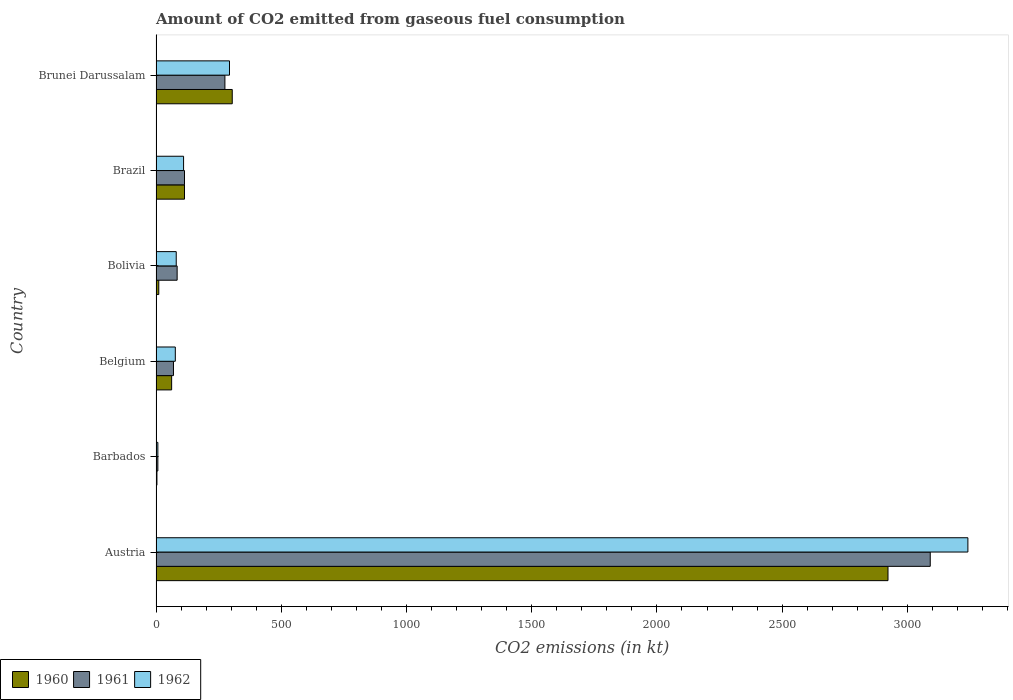How many different coloured bars are there?
Provide a short and direct response. 3. Are the number of bars on each tick of the Y-axis equal?
Make the answer very short. Yes. How many bars are there on the 3rd tick from the top?
Give a very brief answer. 3. How many bars are there on the 3rd tick from the bottom?
Your answer should be very brief. 3. What is the label of the 5th group of bars from the top?
Ensure brevity in your answer.  Barbados. What is the amount of CO2 emitted in 1962 in Barbados?
Offer a terse response. 7.33. Across all countries, what is the maximum amount of CO2 emitted in 1960?
Your response must be concise. 2922.6. Across all countries, what is the minimum amount of CO2 emitted in 1960?
Offer a terse response. 3.67. In which country was the amount of CO2 emitted in 1962 minimum?
Offer a terse response. Barbados. What is the total amount of CO2 emitted in 1961 in the graph?
Make the answer very short. 3641.33. What is the difference between the amount of CO2 emitted in 1960 in Barbados and that in Brunei Darussalam?
Your answer should be very brief. -300.69. What is the difference between the amount of CO2 emitted in 1960 in Brazil and the amount of CO2 emitted in 1962 in Austria?
Offer a very short reply. -3127.95. What is the average amount of CO2 emitted in 1961 per country?
Provide a succinct answer. 606.89. What is the difference between the amount of CO2 emitted in 1960 and amount of CO2 emitted in 1962 in Austria?
Offer a terse response. -319.03. In how many countries, is the amount of CO2 emitted in 1960 greater than 2900 kt?
Your response must be concise. 1. What is the ratio of the amount of CO2 emitted in 1962 in Barbados to that in Belgium?
Keep it short and to the point. 0.1. Is the amount of CO2 emitted in 1962 in Barbados less than that in Brazil?
Your answer should be very brief. Yes. Is the difference between the amount of CO2 emitted in 1960 in Barbados and Brazil greater than the difference between the amount of CO2 emitted in 1962 in Barbados and Brazil?
Your response must be concise. No. What is the difference between the highest and the second highest amount of CO2 emitted in 1960?
Your answer should be compact. 2618.24. What is the difference between the highest and the lowest amount of CO2 emitted in 1962?
Offer a terse response. 3234.29. What does the 3rd bar from the bottom in Brunei Darussalam represents?
Make the answer very short. 1962. How many bars are there?
Make the answer very short. 18. Are all the bars in the graph horizontal?
Ensure brevity in your answer.  Yes. What is the difference between two consecutive major ticks on the X-axis?
Offer a very short reply. 500. Does the graph contain grids?
Provide a succinct answer. No. How many legend labels are there?
Make the answer very short. 3. How are the legend labels stacked?
Your response must be concise. Horizontal. What is the title of the graph?
Offer a terse response. Amount of CO2 emitted from gaseous fuel consumption. What is the label or title of the X-axis?
Make the answer very short. CO2 emissions (in kt). What is the CO2 emissions (in kt) of 1960 in Austria?
Provide a short and direct response. 2922.6. What is the CO2 emissions (in kt) of 1961 in Austria?
Provide a succinct answer. 3091.28. What is the CO2 emissions (in kt) in 1962 in Austria?
Offer a terse response. 3241.63. What is the CO2 emissions (in kt) of 1960 in Barbados?
Provide a succinct answer. 3.67. What is the CO2 emissions (in kt) in 1961 in Barbados?
Ensure brevity in your answer.  7.33. What is the CO2 emissions (in kt) in 1962 in Barbados?
Offer a terse response. 7.33. What is the CO2 emissions (in kt) of 1960 in Belgium?
Your answer should be compact. 62.34. What is the CO2 emissions (in kt) of 1961 in Belgium?
Your response must be concise. 69.67. What is the CO2 emissions (in kt) in 1962 in Belgium?
Give a very brief answer. 77.01. What is the CO2 emissions (in kt) in 1960 in Bolivia?
Your answer should be very brief. 11. What is the CO2 emissions (in kt) of 1961 in Bolivia?
Offer a very short reply. 84.34. What is the CO2 emissions (in kt) in 1962 in Bolivia?
Offer a very short reply. 80.67. What is the CO2 emissions (in kt) of 1960 in Brazil?
Offer a very short reply. 113.68. What is the CO2 emissions (in kt) of 1961 in Brazil?
Give a very brief answer. 113.68. What is the CO2 emissions (in kt) in 1962 in Brazil?
Provide a succinct answer. 110.01. What is the CO2 emissions (in kt) of 1960 in Brunei Darussalam?
Give a very brief answer. 304.36. What is the CO2 emissions (in kt) in 1961 in Brunei Darussalam?
Give a very brief answer. 275.02. What is the CO2 emissions (in kt) in 1962 in Brunei Darussalam?
Provide a short and direct response. 293.36. Across all countries, what is the maximum CO2 emissions (in kt) in 1960?
Ensure brevity in your answer.  2922.6. Across all countries, what is the maximum CO2 emissions (in kt) in 1961?
Your answer should be compact. 3091.28. Across all countries, what is the maximum CO2 emissions (in kt) of 1962?
Keep it short and to the point. 3241.63. Across all countries, what is the minimum CO2 emissions (in kt) in 1960?
Your response must be concise. 3.67. Across all countries, what is the minimum CO2 emissions (in kt) in 1961?
Your answer should be compact. 7.33. Across all countries, what is the minimum CO2 emissions (in kt) of 1962?
Ensure brevity in your answer.  7.33. What is the total CO2 emissions (in kt) in 1960 in the graph?
Provide a short and direct response. 3417.64. What is the total CO2 emissions (in kt) of 1961 in the graph?
Offer a very short reply. 3641.33. What is the total CO2 emissions (in kt) in 1962 in the graph?
Offer a very short reply. 3810.01. What is the difference between the CO2 emissions (in kt) of 1960 in Austria and that in Barbados?
Your answer should be very brief. 2918.93. What is the difference between the CO2 emissions (in kt) in 1961 in Austria and that in Barbados?
Give a very brief answer. 3083.95. What is the difference between the CO2 emissions (in kt) in 1962 in Austria and that in Barbados?
Keep it short and to the point. 3234.29. What is the difference between the CO2 emissions (in kt) in 1960 in Austria and that in Belgium?
Offer a very short reply. 2860.26. What is the difference between the CO2 emissions (in kt) in 1961 in Austria and that in Belgium?
Make the answer very short. 3021.61. What is the difference between the CO2 emissions (in kt) of 1962 in Austria and that in Belgium?
Make the answer very short. 3164.62. What is the difference between the CO2 emissions (in kt) of 1960 in Austria and that in Bolivia?
Provide a short and direct response. 2911.6. What is the difference between the CO2 emissions (in kt) of 1961 in Austria and that in Bolivia?
Your answer should be very brief. 3006.94. What is the difference between the CO2 emissions (in kt) of 1962 in Austria and that in Bolivia?
Your response must be concise. 3160.95. What is the difference between the CO2 emissions (in kt) in 1960 in Austria and that in Brazil?
Ensure brevity in your answer.  2808.92. What is the difference between the CO2 emissions (in kt) of 1961 in Austria and that in Brazil?
Your response must be concise. 2977.6. What is the difference between the CO2 emissions (in kt) in 1962 in Austria and that in Brazil?
Keep it short and to the point. 3131.62. What is the difference between the CO2 emissions (in kt) in 1960 in Austria and that in Brunei Darussalam?
Offer a terse response. 2618.24. What is the difference between the CO2 emissions (in kt) of 1961 in Austria and that in Brunei Darussalam?
Offer a very short reply. 2816.26. What is the difference between the CO2 emissions (in kt) in 1962 in Austria and that in Brunei Darussalam?
Make the answer very short. 2948.27. What is the difference between the CO2 emissions (in kt) in 1960 in Barbados and that in Belgium?
Ensure brevity in your answer.  -58.67. What is the difference between the CO2 emissions (in kt) of 1961 in Barbados and that in Belgium?
Provide a succinct answer. -62.34. What is the difference between the CO2 emissions (in kt) of 1962 in Barbados and that in Belgium?
Provide a succinct answer. -69.67. What is the difference between the CO2 emissions (in kt) in 1960 in Barbados and that in Bolivia?
Provide a succinct answer. -7.33. What is the difference between the CO2 emissions (in kt) in 1961 in Barbados and that in Bolivia?
Offer a terse response. -77.01. What is the difference between the CO2 emissions (in kt) of 1962 in Barbados and that in Bolivia?
Ensure brevity in your answer.  -73.34. What is the difference between the CO2 emissions (in kt) in 1960 in Barbados and that in Brazil?
Offer a very short reply. -110.01. What is the difference between the CO2 emissions (in kt) of 1961 in Barbados and that in Brazil?
Give a very brief answer. -106.34. What is the difference between the CO2 emissions (in kt) of 1962 in Barbados and that in Brazil?
Your answer should be compact. -102.68. What is the difference between the CO2 emissions (in kt) of 1960 in Barbados and that in Brunei Darussalam?
Your answer should be compact. -300.69. What is the difference between the CO2 emissions (in kt) of 1961 in Barbados and that in Brunei Darussalam?
Give a very brief answer. -267.69. What is the difference between the CO2 emissions (in kt) in 1962 in Barbados and that in Brunei Darussalam?
Keep it short and to the point. -286.03. What is the difference between the CO2 emissions (in kt) in 1960 in Belgium and that in Bolivia?
Your answer should be very brief. 51.34. What is the difference between the CO2 emissions (in kt) of 1961 in Belgium and that in Bolivia?
Give a very brief answer. -14.67. What is the difference between the CO2 emissions (in kt) in 1962 in Belgium and that in Bolivia?
Give a very brief answer. -3.67. What is the difference between the CO2 emissions (in kt) in 1960 in Belgium and that in Brazil?
Keep it short and to the point. -51.34. What is the difference between the CO2 emissions (in kt) in 1961 in Belgium and that in Brazil?
Provide a succinct answer. -44. What is the difference between the CO2 emissions (in kt) in 1962 in Belgium and that in Brazil?
Provide a succinct answer. -33. What is the difference between the CO2 emissions (in kt) of 1960 in Belgium and that in Brunei Darussalam?
Your answer should be very brief. -242.02. What is the difference between the CO2 emissions (in kt) of 1961 in Belgium and that in Brunei Darussalam?
Provide a short and direct response. -205.35. What is the difference between the CO2 emissions (in kt) of 1962 in Belgium and that in Brunei Darussalam?
Offer a terse response. -216.35. What is the difference between the CO2 emissions (in kt) in 1960 in Bolivia and that in Brazil?
Your answer should be very brief. -102.68. What is the difference between the CO2 emissions (in kt) in 1961 in Bolivia and that in Brazil?
Your answer should be very brief. -29.34. What is the difference between the CO2 emissions (in kt) in 1962 in Bolivia and that in Brazil?
Provide a succinct answer. -29.34. What is the difference between the CO2 emissions (in kt) of 1960 in Bolivia and that in Brunei Darussalam?
Offer a terse response. -293.36. What is the difference between the CO2 emissions (in kt) in 1961 in Bolivia and that in Brunei Darussalam?
Your answer should be very brief. -190.68. What is the difference between the CO2 emissions (in kt) in 1962 in Bolivia and that in Brunei Darussalam?
Your response must be concise. -212.69. What is the difference between the CO2 emissions (in kt) in 1960 in Brazil and that in Brunei Darussalam?
Give a very brief answer. -190.68. What is the difference between the CO2 emissions (in kt) of 1961 in Brazil and that in Brunei Darussalam?
Offer a very short reply. -161.35. What is the difference between the CO2 emissions (in kt) in 1962 in Brazil and that in Brunei Darussalam?
Give a very brief answer. -183.35. What is the difference between the CO2 emissions (in kt) of 1960 in Austria and the CO2 emissions (in kt) of 1961 in Barbados?
Ensure brevity in your answer.  2915.26. What is the difference between the CO2 emissions (in kt) in 1960 in Austria and the CO2 emissions (in kt) in 1962 in Barbados?
Your answer should be very brief. 2915.26. What is the difference between the CO2 emissions (in kt) of 1961 in Austria and the CO2 emissions (in kt) of 1962 in Barbados?
Give a very brief answer. 3083.95. What is the difference between the CO2 emissions (in kt) in 1960 in Austria and the CO2 emissions (in kt) in 1961 in Belgium?
Offer a terse response. 2852.93. What is the difference between the CO2 emissions (in kt) of 1960 in Austria and the CO2 emissions (in kt) of 1962 in Belgium?
Keep it short and to the point. 2845.59. What is the difference between the CO2 emissions (in kt) of 1961 in Austria and the CO2 emissions (in kt) of 1962 in Belgium?
Make the answer very short. 3014.27. What is the difference between the CO2 emissions (in kt) in 1960 in Austria and the CO2 emissions (in kt) in 1961 in Bolivia?
Give a very brief answer. 2838.26. What is the difference between the CO2 emissions (in kt) in 1960 in Austria and the CO2 emissions (in kt) in 1962 in Bolivia?
Provide a succinct answer. 2841.93. What is the difference between the CO2 emissions (in kt) in 1961 in Austria and the CO2 emissions (in kt) in 1962 in Bolivia?
Provide a succinct answer. 3010.61. What is the difference between the CO2 emissions (in kt) in 1960 in Austria and the CO2 emissions (in kt) in 1961 in Brazil?
Your response must be concise. 2808.92. What is the difference between the CO2 emissions (in kt) in 1960 in Austria and the CO2 emissions (in kt) in 1962 in Brazil?
Your answer should be very brief. 2812.59. What is the difference between the CO2 emissions (in kt) of 1961 in Austria and the CO2 emissions (in kt) of 1962 in Brazil?
Your response must be concise. 2981.27. What is the difference between the CO2 emissions (in kt) in 1960 in Austria and the CO2 emissions (in kt) in 1961 in Brunei Darussalam?
Your answer should be compact. 2647.57. What is the difference between the CO2 emissions (in kt) in 1960 in Austria and the CO2 emissions (in kt) in 1962 in Brunei Darussalam?
Provide a succinct answer. 2629.24. What is the difference between the CO2 emissions (in kt) in 1961 in Austria and the CO2 emissions (in kt) in 1962 in Brunei Darussalam?
Your answer should be compact. 2797.92. What is the difference between the CO2 emissions (in kt) in 1960 in Barbados and the CO2 emissions (in kt) in 1961 in Belgium?
Your answer should be compact. -66.01. What is the difference between the CO2 emissions (in kt) of 1960 in Barbados and the CO2 emissions (in kt) of 1962 in Belgium?
Give a very brief answer. -73.34. What is the difference between the CO2 emissions (in kt) of 1961 in Barbados and the CO2 emissions (in kt) of 1962 in Belgium?
Offer a very short reply. -69.67. What is the difference between the CO2 emissions (in kt) of 1960 in Barbados and the CO2 emissions (in kt) of 1961 in Bolivia?
Ensure brevity in your answer.  -80.67. What is the difference between the CO2 emissions (in kt) of 1960 in Barbados and the CO2 emissions (in kt) of 1962 in Bolivia?
Provide a succinct answer. -77.01. What is the difference between the CO2 emissions (in kt) in 1961 in Barbados and the CO2 emissions (in kt) in 1962 in Bolivia?
Offer a terse response. -73.34. What is the difference between the CO2 emissions (in kt) in 1960 in Barbados and the CO2 emissions (in kt) in 1961 in Brazil?
Provide a succinct answer. -110.01. What is the difference between the CO2 emissions (in kt) in 1960 in Barbados and the CO2 emissions (in kt) in 1962 in Brazil?
Provide a short and direct response. -106.34. What is the difference between the CO2 emissions (in kt) in 1961 in Barbados and the CO2 emissions (in kt) in 1962 in Brazil?
Offer a very short reply. -102.68. What is the difference between the CO2 emissions (in kt) in 1960 in Barbados and the CO2 emissions (in kt) in 1961 in Brunei Darussalam?
Give a very brief answer. -271.36. What is the difference between the CO2 emissions (in kt) in 1960 in Barbados and the CO2 emissions (in kt) in 1962 in Brunei Darussalam?
Your answer should be very brief. -289.69. What is the difference between the CO2 emissions (in kt) in 1961 in Barbados and the CO2 emissions (in kt) in 1962 in Brunei Darussalam?
Your response must be concise. -286.03. What is the difference between the CO2 emissions (in kt) in 1960 in Belgium and the CO2 emissions (in kt) in 1961 in Bolivia?
Keep it short and to the point. -22. What is the difference between the CO2 emissions (in kt) of 1960 in Belgium and the CO2 emissions (in kt) of 1962 in Bolivia?
Provide a short and direct response. -18.34. What is the difference between the CO2 emissions (in kt) of 1961 in Belgium and the CO2 emissions (in kt) of 1962 in Bolivia?
Make the answer very short. -11. What is the difference between the CO2 emissions (in kt) in 1960 in Belgium and the CO2 emissions (in kt) in 1961 in Brazil?
Keep it short and to the point. -51.34. What is the difference between the CO2 emissions (in kt) of 1960 in Belgium and the CO2 emissions (in kt) of 1962 in Brazil?
Make the answer very short. -47.67. What is the difference between the CO2 emissions (in kt) in 1961 in Belgium and the CO2 emissions (in kt) in 1962 in Brazil?
Your answer should be very brief. -40.34. What is the difference between the CO2 emissions (in kt) of 1960 in Belgium and the CO2 emissions (in kt) of 1961 in Brunei Darussalam?
Ensure brevity in your answer.  -212.69. What is the difference between the CO2 emissions (in kt) in 1960 in Belgium and the CO2 emissions (in kt) in 1962 in Brunei Darussalam?
Provide a succinct answer. -231.02. What is the difference between the CO2 emissions (in kt) of 1961 in Belgium and the CO2 emissions (in kt) of 1962 in Brunei Darussalam?
Your answer should be compact. -223.69. What is the difference between the CO2 emissions (in kt) in 1960 in Bolivia and the CO2 emissions (in kt) in 1961 in Brazil?
Provide a short and direct response. -102.68. What is the difference between the CO2 emissions (in kt) of 1960 in Bolivia and the CO2 emissions (in kt) of 1962 in Brazil?
Keep it short and to the point. -99.01. What is the difference between the CO2 emissions (in kt) in 1961 in Bolivia and the CO2 emissions (in kt) in 1962 in Brazil?
Offer a very short reply. -25.67. What is the difference between the CO2 emissions (in kt) in 1960 in Bolivia and the CO2 emissions (in kt) in 1961 in Brunei Darussalam?
Provide a succinct answer. -264.02. What is the difference between the CO2 emissions (in kt) of 1960 in Bolivia and the CO2 emissions (in kt) of 1962 in Brunei Darussalam?
Your answer should be very brief. -282.36. What is the difference between the CO2 emissions (in kt) of 1961 in Bolivia and the CO2 emissions (in kt) of 1962 in Brunei Darussalam?
Offer a very short reply. -209.02. What is the difference between the CO2 emissions (in kt) in 1960 in Brazil and the CO2 emissions (in kt) in 1961 in Brunei Darussalam?
Provide a short and direct response. -161.35. What is the difference between the CO2 emissions (in kt) in 1960 in Brazil and the CO2 emissions (in kt) in 1962 in Brunei Darussalam?
Keep it short and to the point. -179.68. What is the difference between the CO2 emissions (in kt) of 1961 in Brazil and the CO2 emissions (in kt) of 1962 in Brunei Darussalam?
Your answer should be very brief. -179.68. What is the average CO2 emissions (in kt) of 1960 per country?
Make the answer very short. 569.61. What is the average CO2 emissions (in kt) in 1961 per country?
Offer a terse response. 606.89. What is the average CO2 emissions (in kt) of 1962 per country?
Provide a short and direct response. 635. What is the difference between the CO2 emissions (in kt) in 1960 and CO2 emissions (in kt) in 1961 in Austria?
Ensure brevity in your answer.  -168.68. What is the difference between the CO2 emissions (in kt) of 1960 and CO2 emissions (in kt) of 1962 in Austria?
Your answer should be compact. -319.03. What is the difference between the CO2 emissions (in kt) of 1961 and CO2 emissions (in kt) of 1962 in Austria?
Give a very brief answer. -150.35. What is the difference between the CO2 emissions (in kt) in 1960 and CO2 emissions (in kt) in 1961 in Barbados?
Make the answer very short. -3.67. What is the difference between the CO2 emissions (in kt) of 1960 and CO2 emissions (in kt) of 1962 in Barbados?
Your answer should be compact. -3.67. What is the difference between the CO2 emissions (in kt) of 1961 and CO2 emissions (in kt) of 1962 in Barbados?
Ensure brevity in your answer.  0. What is the difference between the CO2 emissions (in kt) in 1960 and CO2 emissions (in kt) in 1961 in Belgium?
Keep it short and to the point. -7.33. What is the difference between the CO2 emissions (in kt) of 1960 and CO2 emissions (in kt) of 1962 in Belgium?
Your response must be concise. -14.67. What is the difference between the CO2 emissions (in kt) in 1961 and CO2 emissions (in kt) in 1962 in Belgium?
Provide a short and direct response. -7.33. What is the difference between the CO2 emissions (in kt) of 1960 and CO2 emissions (in kt) of 1961 in Bolivia?
Give a very brief answer. -73.34. What is the difference between the CO2 emissions (in kt) in 1960 and CO2 emissions (in kt) in 1962 in Bolivia?
Provide a short and direct response. -69.67. What is the difference between the CO2 emissions (in kt) of 1961 and CO2 emissions (in kt) of 1962 in Bolivia?
Offer a terse response. 3.67. What is the difference between the CO2 emissions (in kt) of 1960 and CO2 emissions (in kt) of 1962 in Brazil?
Keep it short and to the point. 3.67. What is the difference between the CO2 emissions (in kt) of 1961 and CO2 emissions (in kt) of 1962 in Brazil?
Your answer should be compact. 3.67. What is the difference between the CO2 emissions (in kt) in 1960 and CO2 emissions (in kt) in 1961 in Brunei Darussalam?
Make the answer very short. 29.34. What is the difference between the CO2 emissions (in kt) in 1960 and CO2 emissions (in kt) in 1962 in Brunei Darussalam?
Provide a succinct answer. 11. What is the difference between the CO2 emissions (in kt) of 1961 and CO2 emissions (in kt) of 1962 in Brunei Darussalam?
Your response must be concise. -18.34. What is the ratio of the CO2 emissions (in kt) in 1960 in Austria to that in Barbados?
Provide a succinct answer. 797. What is the ratio of the CO2 emissions (in kt) of 1961 in Austria to that in Barbados?
Provide a succinct answer. 421.5. What is the ratio of the CO2 emissions (in kt) in 1962 in Austria to that in Barbados?
Make the answer very short. 442. What is the ratio of the CO2 emissions (in kt) of 1960 in Austria to that in Belgium?
Keep it short and to the point. 46.88. What is the ratio of the CO2 emissions (in kt) of 1961 in Austria to that in Belgium?
Your answer should be compact. 44.37. What is the ratio of the CO2 emissions (in kt) in 1962 in Austria to that in Belgium?
Your answer should be very brief. 42.1. What is the ratio of the CO2 emissions (in kt) in 1960 in Austria to that in Bolivia?
Your response must be concise. 265.67. What is the ratio of the CO2 emissions (in kt) of 1961 in Austria to that in Bolivia?
Your answer should be very brief. 36.65. What is the ratio of the CO2 emissions (in kt) in 1962 in Austria to that in Bolivia?
Your answer should be very brief. 40.18. What is the ratio of the CO2 emissions (in kt) in 1960 in Austria to that in Brazil?
Give a very brief answer. 25.71. What is the ratio of the CO2 emissions (in kt) of 1961 in Austria to that in Brazil?
Your answer should be compact. 27.19. What is the ratio of the CO2 emissions (in kt) in 1962 in Austria to that in Brazil?
Make the answer very short. 29.47. What is the ratio of the CO2 emissions (in kt) of 1960 in Austria to that in Brunei Darussalam?
Offer a terse response. 9.6. What is the ratio of the CO2 emissions (in kt) in 1961 in Austria to that in Brunei Darussalam?
Your response must be concise. 11.24. What is the ratio of the CO2 emissions (in kt) of 1962 in Austria to that in Brunei Darussalam?
Offer a terse response. 11.05. What is the ratio of the CO2 emissions (in kt) in 1960 in Barbados to that in Belgium?
Your response must be concise. 0.06. What is the ratio of the CO2 emissions (in kt) of 1961 in Barbados to that in Belgium?
Your answer should be compact. 0.11. What is the ratio of the CO2 emissions (in kt) of 1962 in Barbados to that in Belgium?
Ensure brevity in your answer.  0.1. What is the ratio of the CO2 emissions (in kt) in 1961 in Barbados to that in Bolivia?
Keep it short and to the point. 0.09. What is the ratio of the CO2 emissions (in kt) of 1962 in Barbados to that in Bolivia?
Provide a succinct answer. 0.09. What is the ratio of the CO2 emissions (in kt) in 1960 in Barbados to that in Brazil?
Make the answer very short. 0.03. What is the ratio of the CO2 emissions (in kt) of 1961 in Barbados to that in Brazil?
Give a very brief answer. 0.06. What is the ratio of the CO2 emissions (in kt) in 1962 in Barbados to that in Brazil?
Your response must be concise. 0.07. What is the ratio of the CO2 emissions (in kt) of 1960 in Barbados to that in Brunei Darussalam?
Your answer should be very brief. 0.01. What is the ratio of the CO2 emissions (in kt) in 1961 in Barbados to that in Brunei Darussalam?
Ensure brevity in your answer.  0.03. What is the ratio of the CO2 emissions (in kt) of 1962 in Barbados to that in Brunei Darussalam?
Offer a very short reply. 0.03. What is the ratio of the CO2 emissions (in kt) of 1960 in Belgium to that in Bolivia?
Your response must be concise. 5.67. What is the ratio of the CO2 emissions (in kt) of 1961 in Belgium to that in Bolivia?
Your response must be concise. 0.83. What is the ratio of the CO2 emissions (in kt) of 1962 in Belgium to that in Bolivia?
Your answer should be compact. 0.95. What is the ratio of the CO2 emissions (in kt) of 1960 in Belgium to that in Brazil?
Ensure brevity in your answer.  0.55. What is the ratio of the CO2 emissions (in kt) of 1961 in Belgium to that in Brazil?
Ensure brevity in your answer.  0.61. What is the ratio of the CO2 emissions (in kt) of 1962 in Belgium to that in Brazil?
Your answer should be compact. 0.7. What is the ratio of the CO2 emissions (in kt) of 1960 in Belgium to that in Brunei Darussalam?
Ensure brevity in your answer.  0.2. What is the ratio of the CO2 emissions (in kt) of 1961 in Belgium to that in Brunei Darussalam?
Offer a terse response. 0.25. What is the ratio of the CO2 emissions (in kt) in 1962 in Belgium to that in Brunei Darussalam?
Ensure brevity in your answer.  0.26. What is the ratio of the CO2 emissions (in kt) in 1960 in Bolivia to that in Brazil?
Provide a succinct answer. 0.1. What is the ratio of the CO2 emissions (in kt) of 1961 in Bolivia to that in Brazil?
Offer a very short reply. 0.74. What is the ratio of the CO2 emissions (in kt) in 1962 in Bolivia to that in Brazil?
Offer a very short reply. 0.73. What is the ratio of the CO2 emissions (in kt) in 1960 in Bolivia to that in Brunei Darussalam?
Your answer should be compact. 0.04. What is the ratio of the CO2 emissions (in kt) in 1961 in Bolivia to that in Brunei Darussalam?
Keep it short and to the point. 0.31. What is the ratio of the CO2 emissions (in kt) of 1962 in Bolivia to that in Brunei Darussalam?
Your answer should be very brief. 0.28. What is the ratio of the CO2 emissions (in kt) in 1960 in Brazil to that in Brunei Darussalam?
Your response must be concise. 0.37. What is the ratio of the CO2 emissions (in kt) in 1961 in Brazil to that in Brunei Darussalam?
Your answer should be compact. 0.41. What is the ratio of the CO2 emissions (in kt) in 1962 in Brazil to that in Brunei Darussalam?
Make the answer very short. 0.38. What is the difference between the highest and the second highest CO2 emissions (in kt) of 1960?
Keep it short and to the point. 2618.24. What is the difference between the highest and the second highest CO2 emissions (in kt) of 1961?
Offer a very short reply. 2816.26. What is the difference between the highest and the second highest CO2 emissions (in kt) of 1962?
Keep it short and to the point. 2948.27. What is the difference between the highest and the lowest CO2 emissions (in kt) of 1960?
Ensure brevity in your answer.  2918.93. What is the difference between the highest and the lowest CO2 emissions (in kt) of 1961?
Provide a short and direct response. 3083.95. What is the difference between the highest and the lowest CO2 emissions (in kt) in 1962?
Give a very brief answer. 3234.29. 